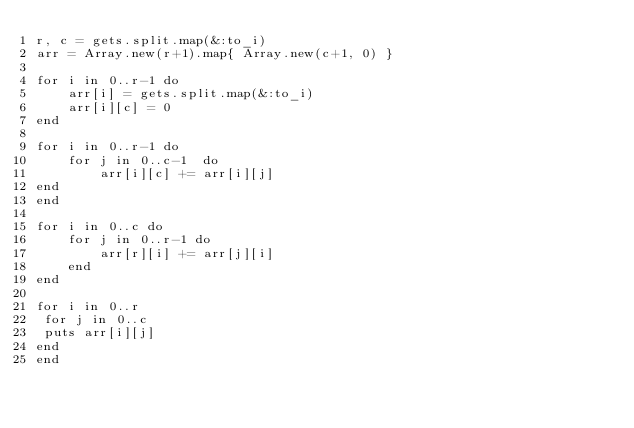<code> <loc_0><loc_0><loc_500><loc_500><_Ruby_>r, c = gets.split.map(&:to_i)
arr = Array.new(r+1).map{ Array.new(c+1, 0) }

for i in 0..r-1 do
    arr[i] = gets.split.map(&:to_i)
    arr[i][c] = 0
end

for i in 0..r-1 do
    for j in 0..c-1  do
        arr[i][c] += arr[i][j]
end
end

for i in 0..c do
    for j in 0..r-1 do
        arr[r][i] += arr[j][i] 
    end
end

for i in 0..r
 for j in 0..c
 puts arr[i][j]
end
end
</code> 